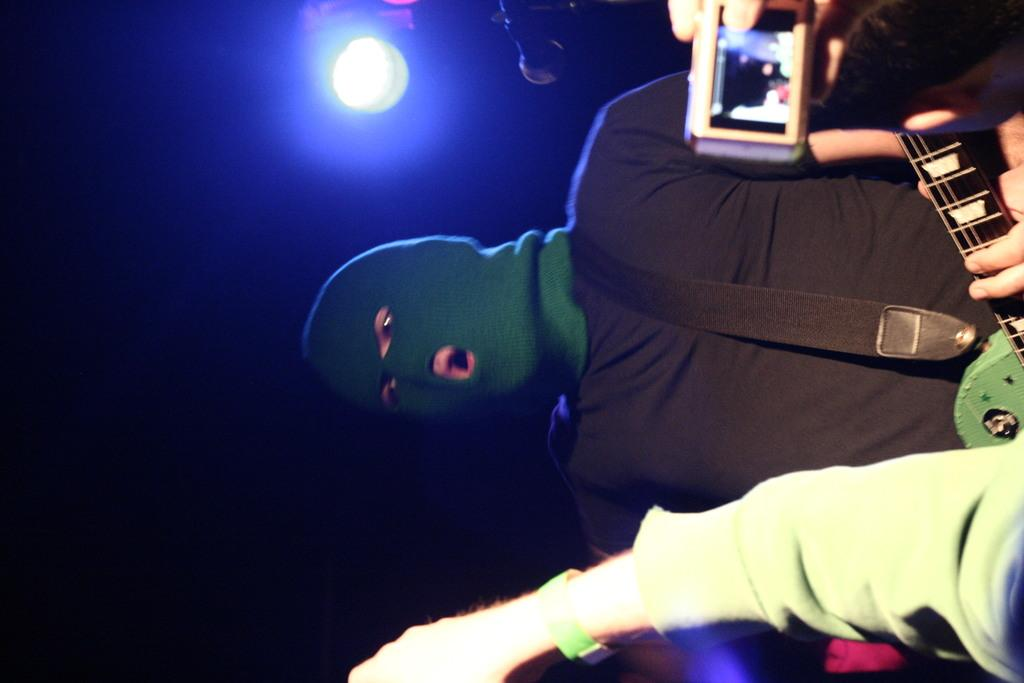What is the person in the image wearing on their face? The person in the image is wearing a mask. What is the person's posture in the image? The person is standing. What can be seen at the top of the image? There is light visible at the top of the image. What is visible at the bottom of the image? There is a person's hand visible at the bottom of the image. What type of committee is meeting in the image? There is no committee meeting in the image; it only features a person wearing a mask. What kind of ray is emanating from the person's hand in the image? There is no ray visible in the image; only a person's hand is present. 